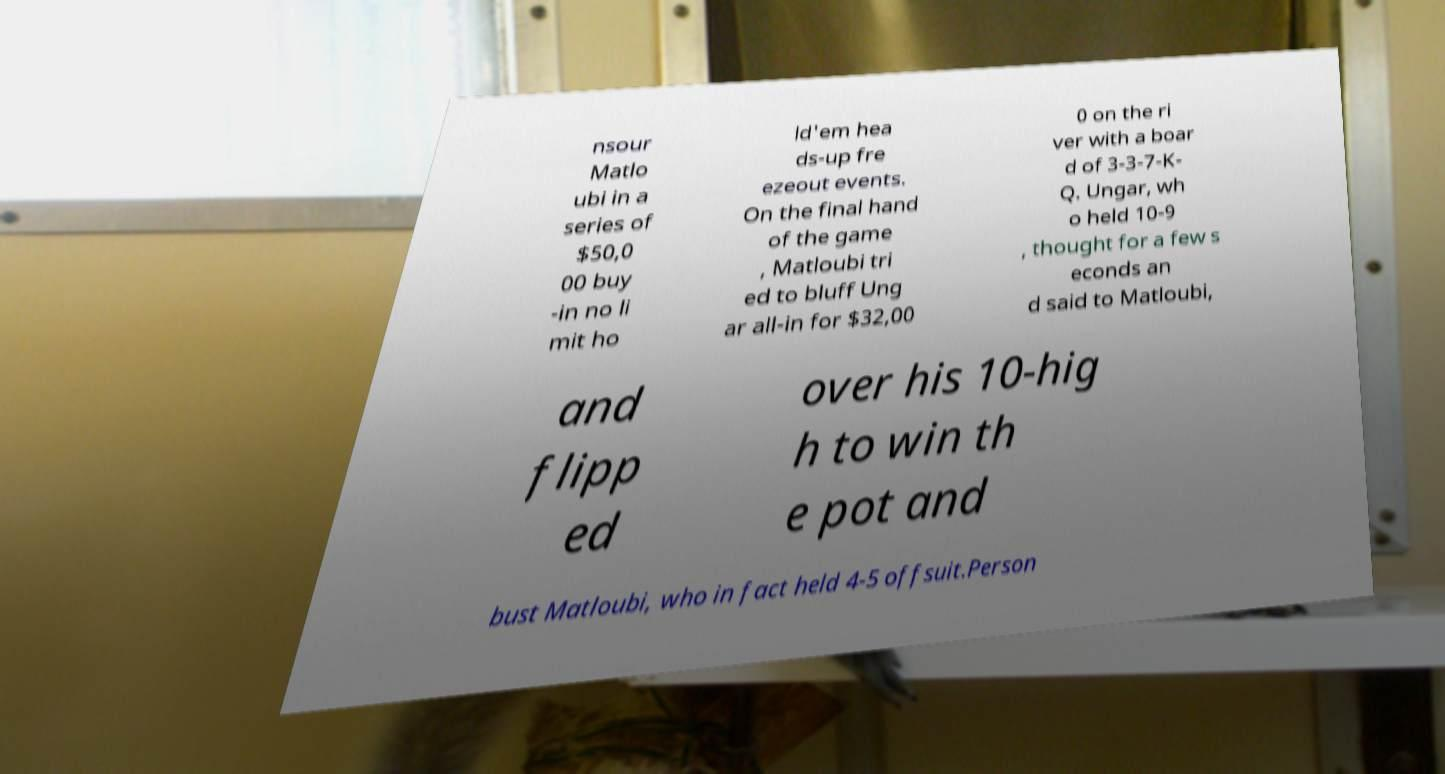Could you assist in decoding the text presented in this image and type it out clearly? nsour Matlo ubi in a series of $50,0 00 buy -in no li mit ho ld'em hea ds-up fre ezeout events. On the final hand of the game , Matloubi tri ed to bluff Ung ar all-in for $32,00 0 on the ri ver with a boar d of 3-3-7-K- Q. Ungar, wh o held 10-9 , thought for a few s econds an d said to Matloubi, and flipp ed over his 10-hig h to win th e pot and bust Matloubi, who in fact held 4-5 offsuit.Person 